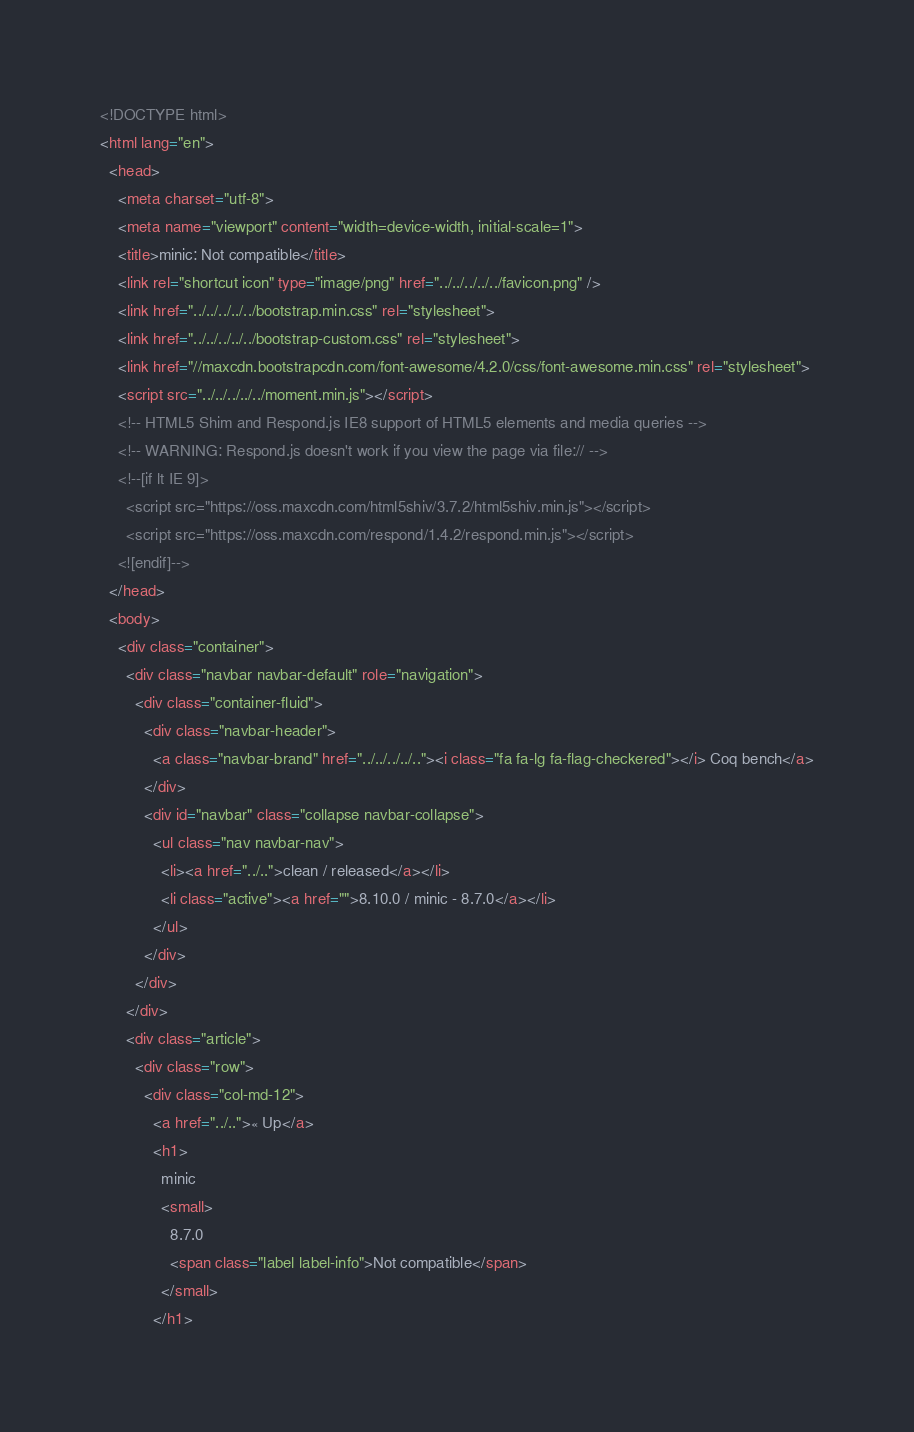<code> <loc_0><loc_0><loc_500><loc_500><_HTML_><!DOCTYPE html>
<html lang="en">
  <head>
    <meta charset="utf-8">
    <meta name="viewport" content="width=device-width, initial-scale=1">
    <title>minic: Not compatible</title>
    <link rel="shortcut icon" type="image/png" href="../../../../../favicon.png" />
    <link href="../../../../../bootstrap.min.css" rel="stylesheet">
    <link href="../../../../../bootstrap-custom.css" rel="stylesheet">
    <link href="//maxcdn.bootstrapcdn.com/font-awesome/4.2.0/css/font-awesome.min.css" rel="stylesheet">
    <script src="../../../../../moment.min.js"></script>
    <!-- HTML5 Shim and Respond.js IE8 support of HTML5 elements and media queries -->
    <!-- WARNING: Respond.js doesn't work if you view the page via file:// -->
    <!--[if lt IE 9]>
      <script src="https://oss.maxcdn.com/html5shiv/3.7.2/html5shiv.min.js"></script>
      <script src="https://oss.maxcdn.com/respond/1.4.2/respond.min.js"></script>
    <![endif]-->
  </head>
  <body>
    <div class="container">
      <div class="navbar navbar-default" role="navigation">
        <div class="container-fluid">
          <div class="navbar-header">
            <a class="navbar-brand" href="../../../../.."><i class="fa fa-lg fa-flag-checkered"></i> Coq bench</a>
          </div>
          <div id="navbar" class="collapse navbar-collapse">
            <ul class="nav navbar-nav">
              <li><a href="../..">clean / released</a></li>
              <li class="active"><a href="">8.10.0 / minic - 8.7.0</a></li>
            </ul>
          </div>
        </div>
      </div>
      <div class="article">
        <div class="row">
          <div class="col-md-12">
            <a href="../..">« Up</a>
            <h1>
              minic
              <small>
                8.7.0
                <span class="label label-info">Not compatible</span>
              </small>
            </h1></code> 